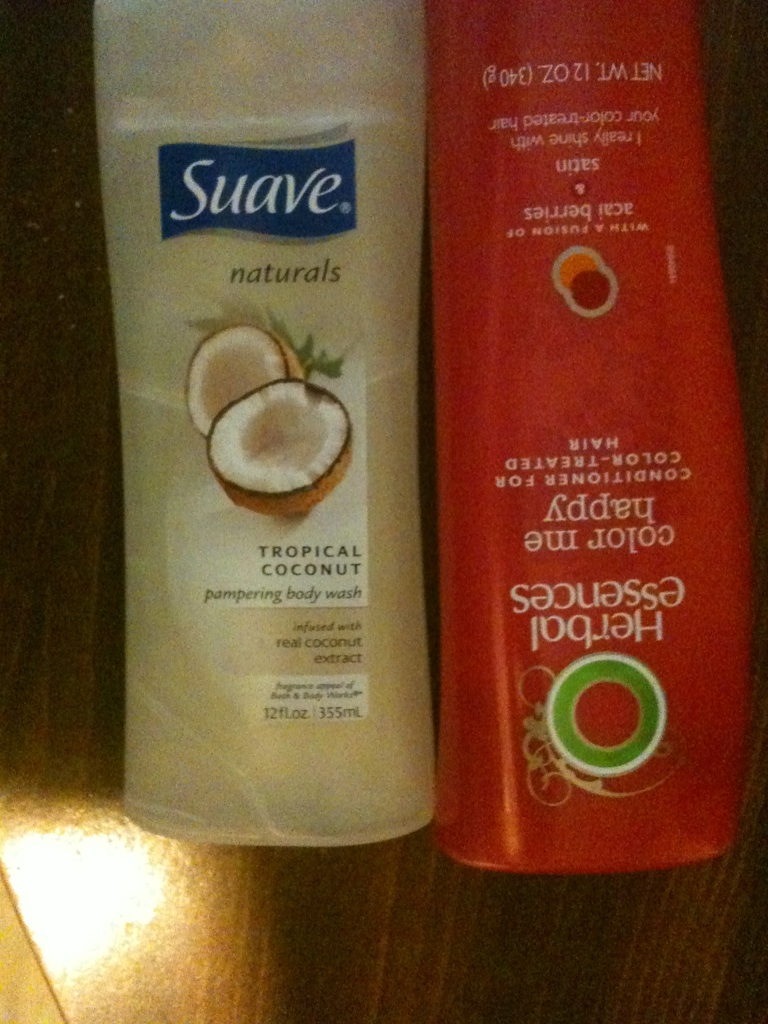Describe a detailed scenario where these products offer the best care. Imagine a person who loves taking luxurious and pampering showers. They begin their shower with warm water to relax their muscles. First, they reach for the Suave Tropical Coconut Pampering Body Wash. As they lather up, the tropical coconut scent fills the air, transporting them to a serene beach. The real coconut extract in the body wash nourishes and moisturizes their skin, leaving it soft and smooth. After rinsing off the lather, they move on to Herbal Essences Color Me Happy Conditioner. They apply the conditioner to their color-treated hair, knowing it is packed with antioxidants and moisturizing agents that help protect and enhance their hair's vibrancy. They let the conditioner sit for a few minutes, enjoying the fruity, refreshing fragrance, before rinsing it out. When they step out of the shower, their skin feels pampered and soft, and their hair looks radiant and shiny. This is their perfect self-care ritual, where both products work in harmony to make them feel refreshed, pampered, and beautiful. 